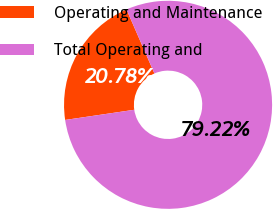Convert chart. <chart><loc_0><loc_0><loc_500><loc_500><pie_chart><fcel>Operating and Maintenance<fcel>Total Operating and<nl><fcel>20.78%<fcel>79.22%<nl></chart> 